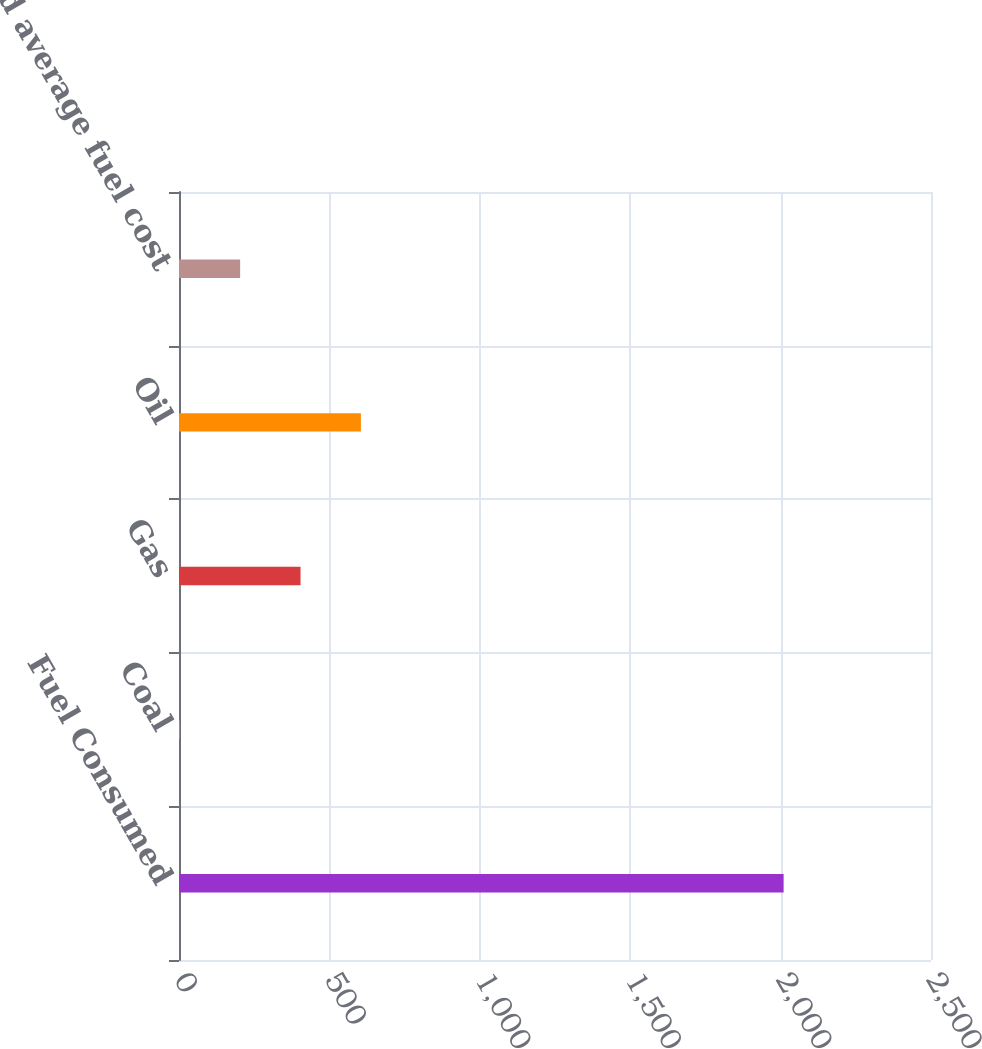<chart> <loc_0><loc_0><loc_500><loc_500><bar_chart><fcel>Fuel Consumed<fcel>Coal<fcel>Gas<fcel>Oil<fcel>Weighted average fuel cost<nl><fcel>2010<fcel>2.51<fcel>404.01<fcel>604.76<fcel>203.26<nl></chart> 